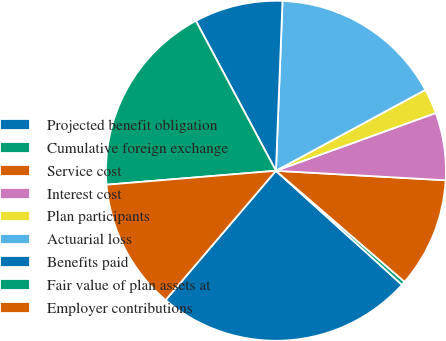<chart> <loc_0><loc_0><loc_500><loc_500><pie_chart><fcel>Projected benefit obligation<fcel>Cumulative foreign exchange<fcel>Service cost<fcel>Interest cost<fcel>Plan participants<fcel>Actuarial loss<fcel>Benefits paid<fcel>Fair value of plan assets at<fcel>Employer contributions<nl><fcel>24.54%<fcel>0.37%<fcel>10.44%<fcel>6.41%<fcel>2.38%<fcel>16.48%<fcel>8.42%<fcel>18.5%<fcel>12.45%<nl></chart> 